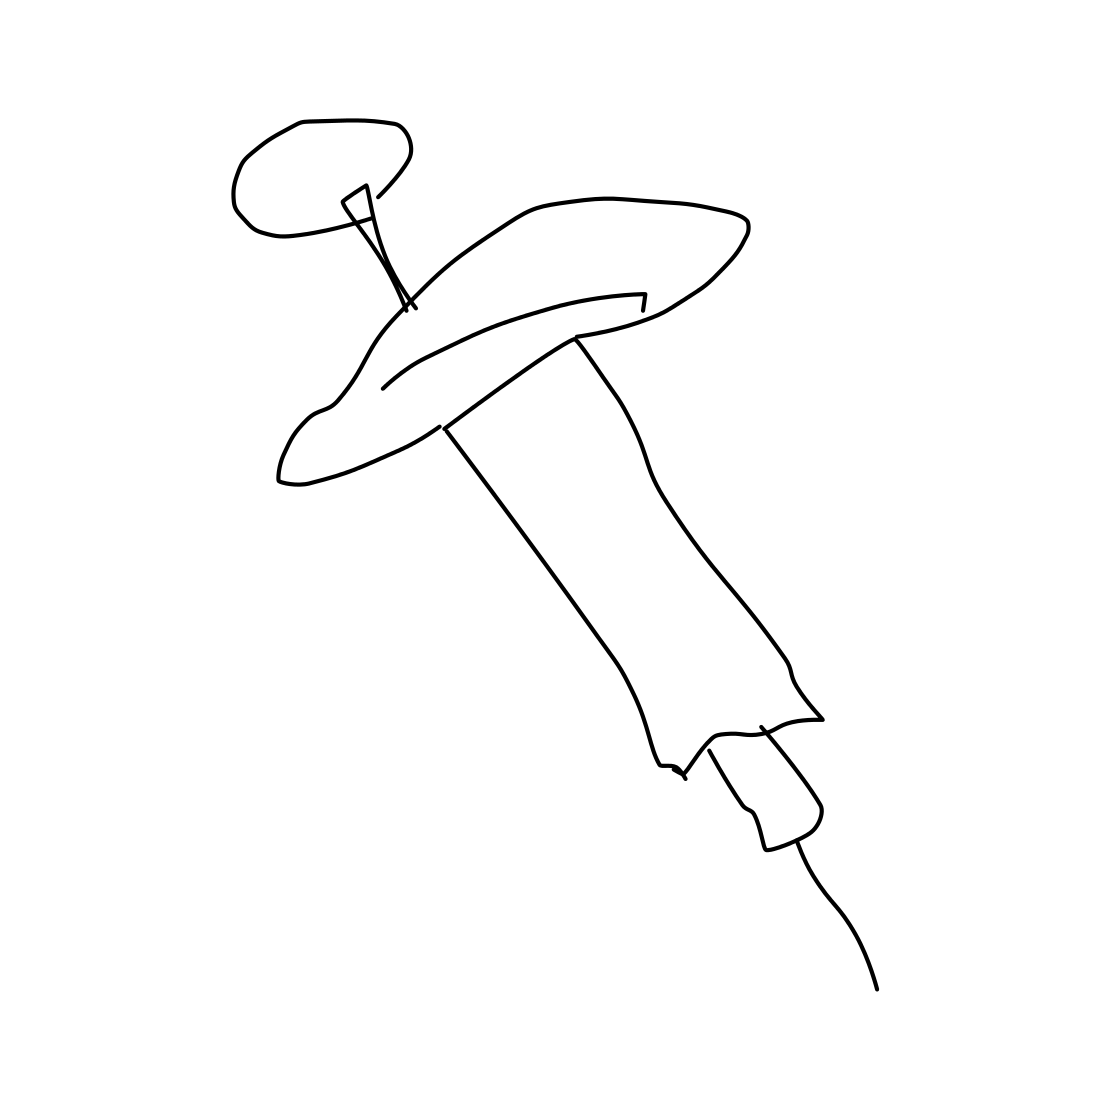In the scene, is a syringe in it? Yes, the image clearly depicts a syringe with a detailed outline showcasing the plunger, barrel, needle, and other typical components of a syringe. 